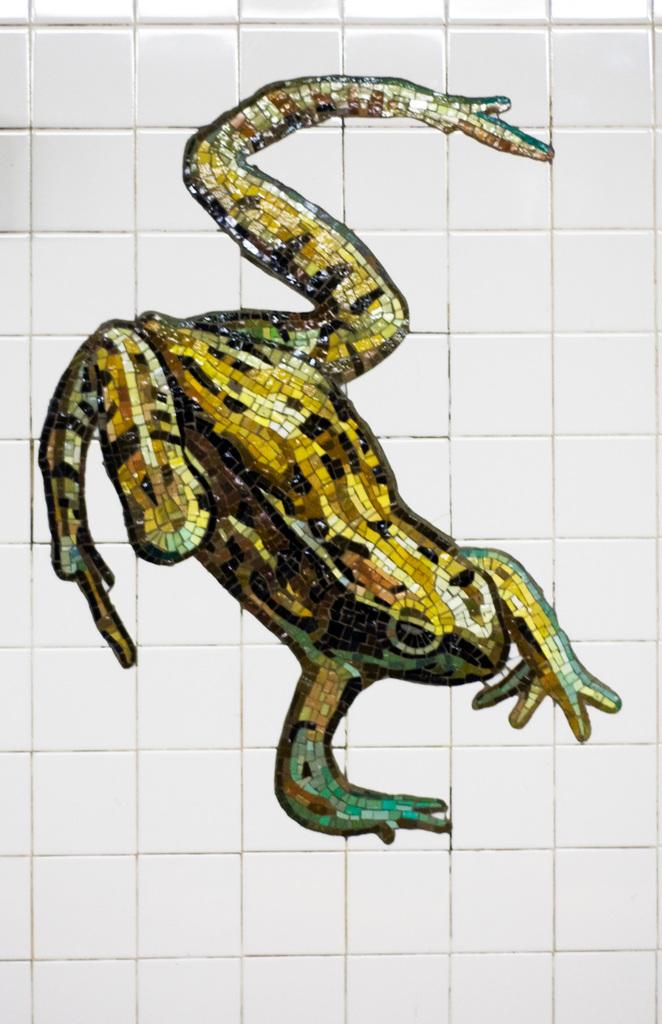What is the focus of the image? The image is zoomed in on a wall art of a frog in the center. What color is the wall in the image? The wall is white in color. What type of orange is the sister holding in the image? There is no orange or sister present in the image; it features a wall art of a frog on a white wall. 